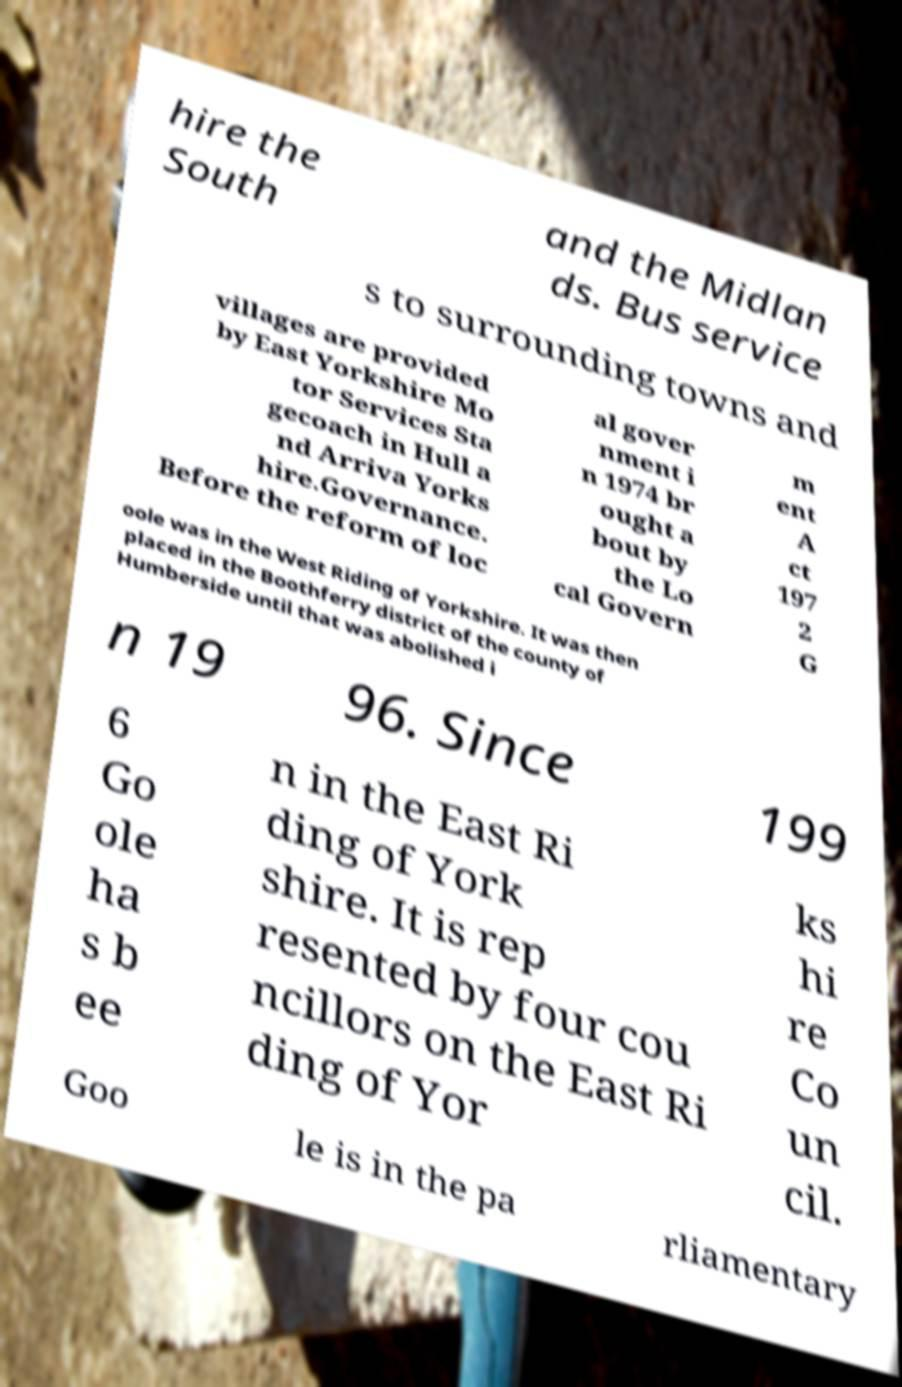Please read and relay the text visible in this image. What does it say? hire the South and the Midlan ds. Bus service s to surrounding towns and villages are provided by East Yorkshire Mo tor Services Sta gecoach in Hull a nd Arriva Yorks hire.Governance. Before the reform of loc al gover nment i n 1974 br ought a bout by the Lo cal Govern m ent A ct 197 2 G oole was in the West Riding of Yorkshire. It was then placed in the Boothferry district of the county of Humberside until that was abolished i n 19 96. Since 199 6 Go ole ha s b ee n in the East Ri ding of York shire. It is rep resented by four cou ncillors on the East Ri ding of Yor ks hi re Co un cil. Goo le is in the pa rliamentary 